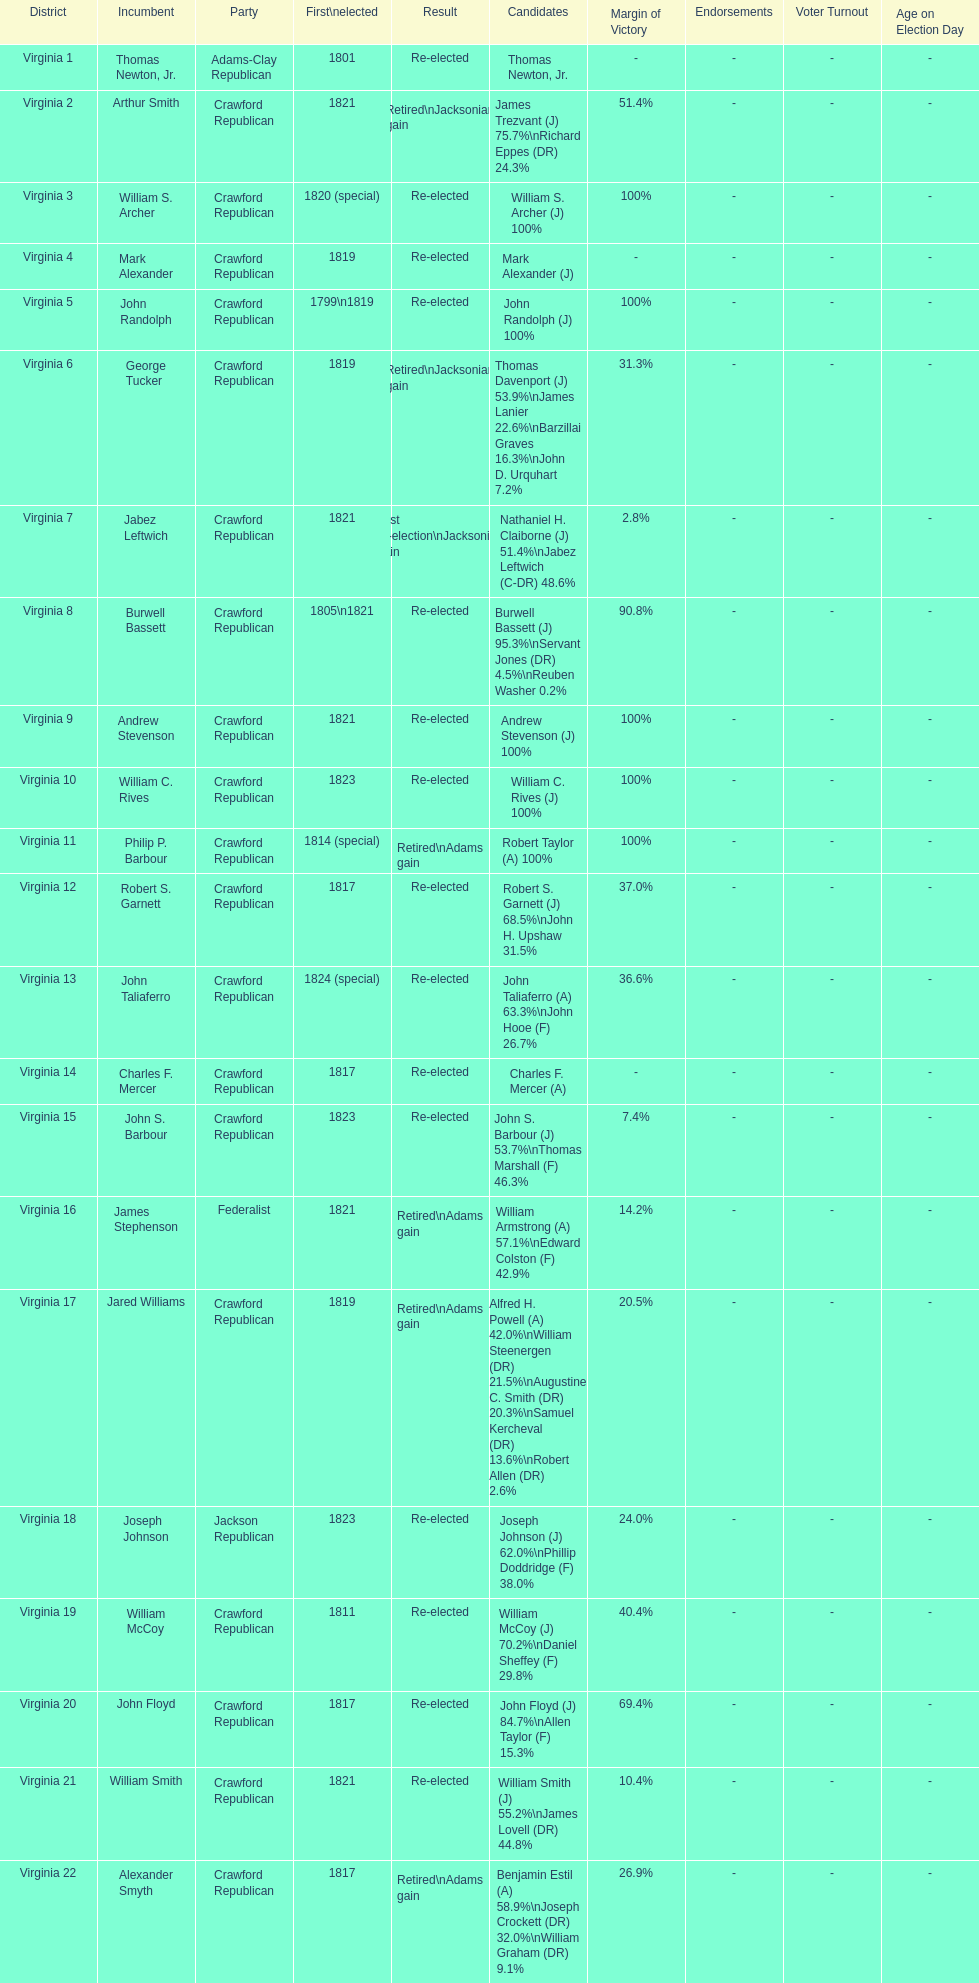What is the last party on this chart? Crawford Republican. 